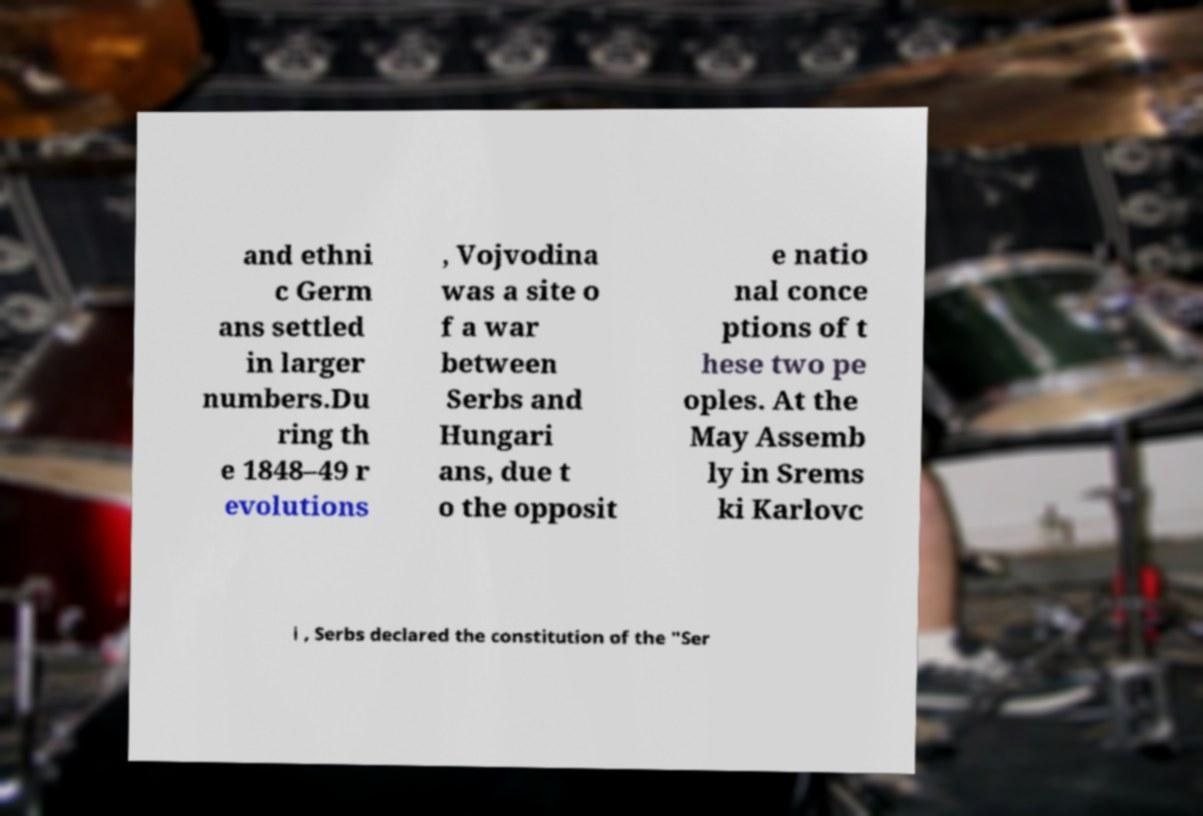Could you assist in decoding the text presented in this image and type it out clearly? and ethni c Germ ans settled in larger numbers.Du ring th e 1848–49 r evolutions , Vojvodina was a site o f a war between Serbs and Hungari ans, due t o the opposit e natio nal conce ptions of t hese two pe oples. At the May Assemb ly in Srems ki Karlovc i , Serbs declared the constitution of the "Ser 